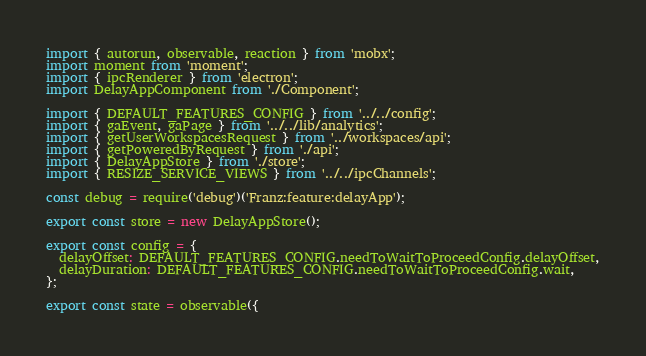<code> <loc_0><loc_0><loc_500><loc_500><_JavaScript_>import { autorun, observable, reaction } from 'mobx';
import moment from 'moment';
import { ipcRenderer } from 'electron';
import DelayAppComponent from './Component';

import { DEFAULT_FEATURES_CONFIG } from '../../config';
import { gaEvent, gaPage } from '../../lib/analytics';
import { getUserWorkspacesRequest } from '../workspaces/api';
import { getPoweredByRequest } from './api';
import { DelayAppStore } from './store';
import { RESIZE_SERVICE_VIEWS } from '../../ipcChannels';

const debug = require('debug')('Franz:feature:delayApp');

export const store = new DelayAppStore();

export const config = {
  delayOffset: DEFAULT_FEATURES_CONFIG.needToWaitToProceedConfig.delayOffset,
  delayDuration: DEFAULT_FEATURES_CONFIG.needToWaitToProceedConfig.wait,
};

export const state = observable({</code> 